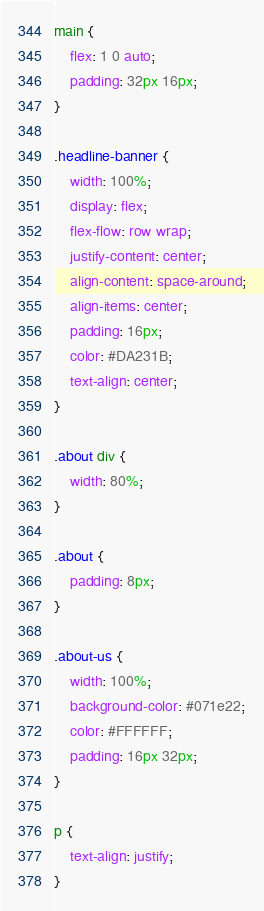<code> <loc_0><loc_0><loc_500><loc_500><_CSS_>main {
    flex: 1 0 auto;
    padding: 32px 16px;
}

.headline-banner {
    width: 100%;
    display: flex;
    flex-flow: row wrap;
    justify-content: center;
    align-content: space-around;
    align-items: center;
    padding: 16px;
    color: #DA231B;
    text-align: center;
}

.about div {
    width: 80%;
}

.about {
    padding: 8px;
}

.about-us {
    width: 100%;
    background-color: #071e22;
    color: #FFFFFF;
    padding: 16px 32px;
}

p {
    text-align: justify;
}</code> 